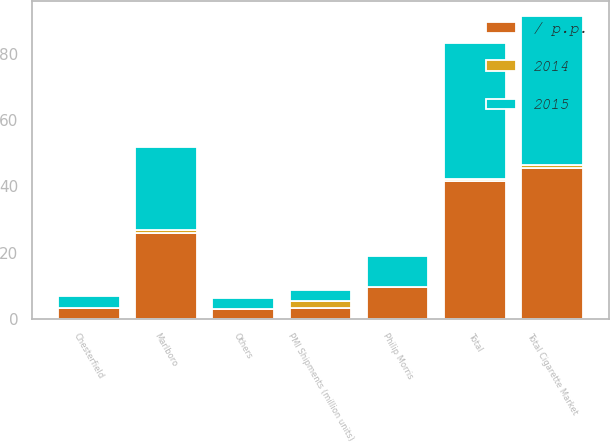Convert chart. <chart><loc_0><loc_0><loc_500><loc_500><stacked_bar_chart><ecel><fcel>Total Cigarette Market<fcel>PMI Shipments (million units)<fcel>Marlboro<fcel>Philip Morris<fcel>Chesterfield<fcel>Others<fcel>Total<nl><fcel>/ p.p.<fcel>45.5<fcel>3.3<fcel>25.9<fcel>9.5<fcel>3.3<fcel>2.9<fcel>41.6<nl><fcel>2015<fcel>45<fcel>3.3<fcel>25.1<fcel>9.4<fcel>3.4<fcel>3.1<fcel>41<nl><fcel>2014<fcel>1<fcel>2<fcel>0.8<fcel>0.1<fcel>0.1<fcel>0.2<fcel>0.6<nl></chart> 